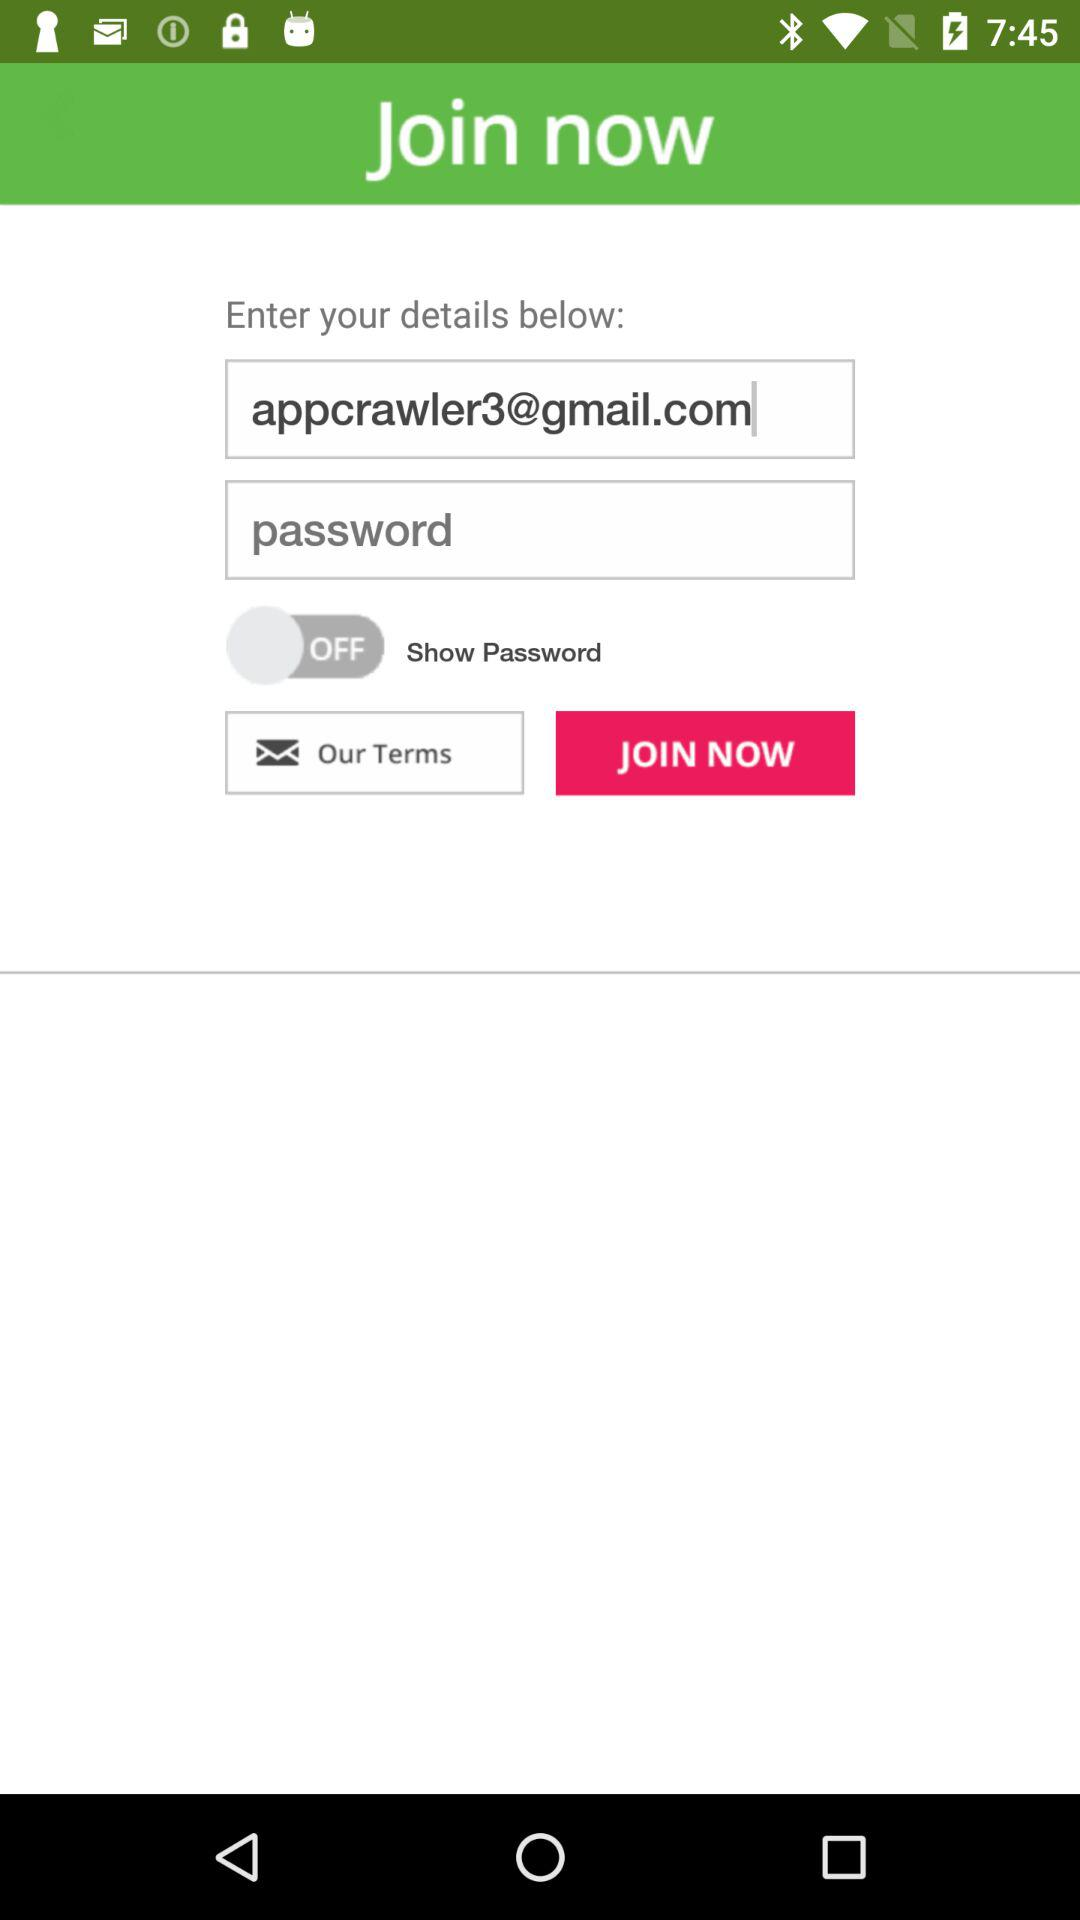What is the status of "Show Password"? The status is "off". 